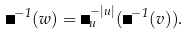<formula> <loc_0><loc_0><loc_500><loc_500>\Phi ^ { - 1 } ( w ) = \Delta ^ { - | u | } _ { u } ( \Phi ^ { - 1 } ( v ) ) .</formula> 